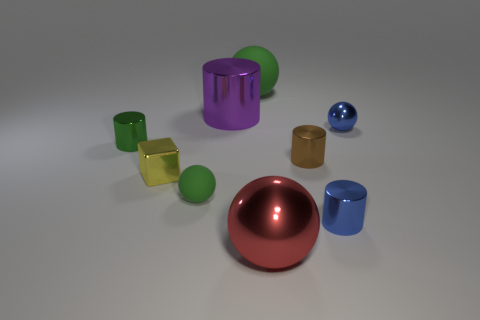Add 1 big purple cylinders. How many objects exist? 10 Subtract all cylinders. How many objects are left? 5 Subtract all big matte objects. Subtract all tiny green spheres. How many objects are left? 7 Add 8 matte spheres. How many matte spheres are left? 10 Add 5 shiny blocks. How many shiny blocks exist? 6 Subtract 1 blue balls. How many objects are left? 8 